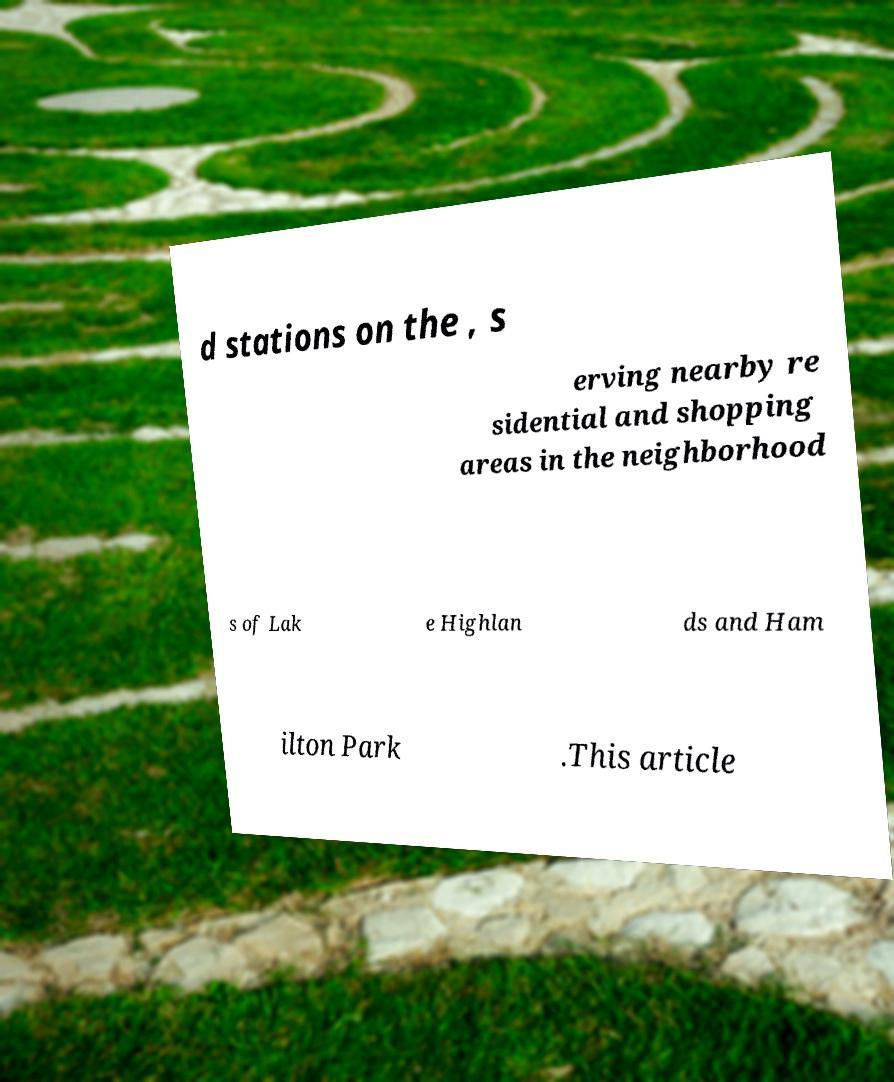Can you accurately transcribe the text from the provided image for me? d stations on the , s erving nearby re sidential and shopping areas in the neighborhood s of Lak e Highlan ds and Ham ilton Park .This article 